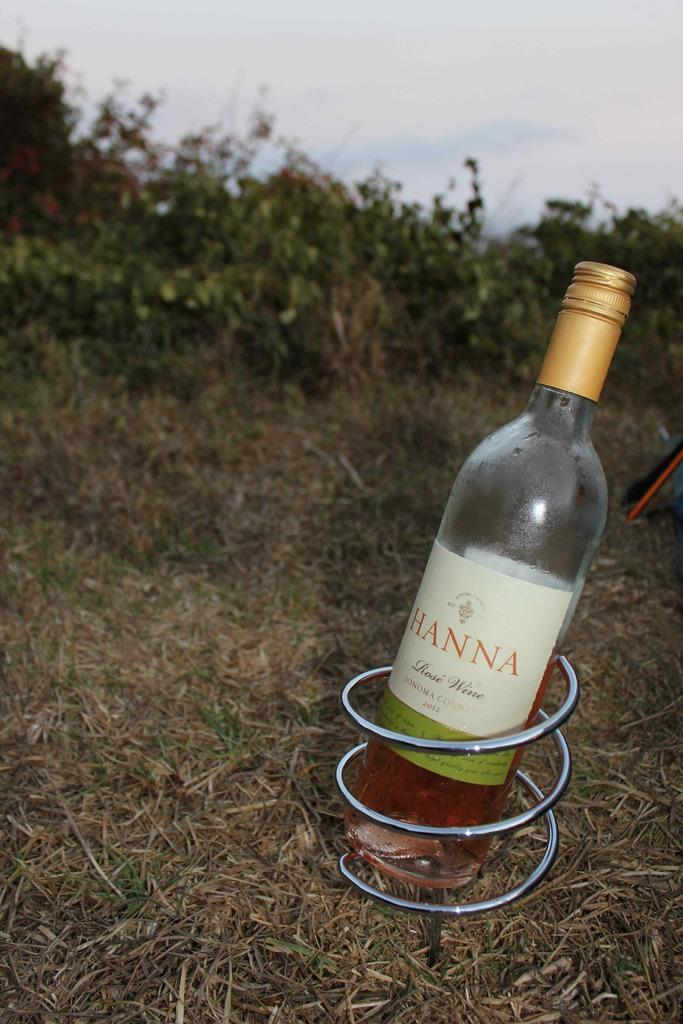What object can be seen in the image that is typically used for holding liquids? There is a bottle in the image that is typically used for holding liquids. What is on the bottle? The bottle has a sticker on it. What is attached to the bottle? The bottle has a ring on it. Where is the bottle located? The bottle is on the grass. What type of natural environment is visible in the image? Trees and the sky are visible in the image. Can you see a patch of kitty fur on the bottle in the image? There is no patch of kitty fur on the bottle in the image. What channel is the bottle tuned to in the image? The bottle is not a television or device that can be tuned to a channel, so this question cannot be answered. 